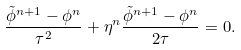<formula> <loc_0><loc_0><loc_500><loc_500>\frac { \tilde { \phi } ^ { n + 1 } - \phi ^ { n } } { \tau ^ { 2 } } + \eta ^ { n } \frac { \tilde { \phi } ^ { n + 1 } - \phi ^ { n } } { 2 \tau } = 0 .</formula> 